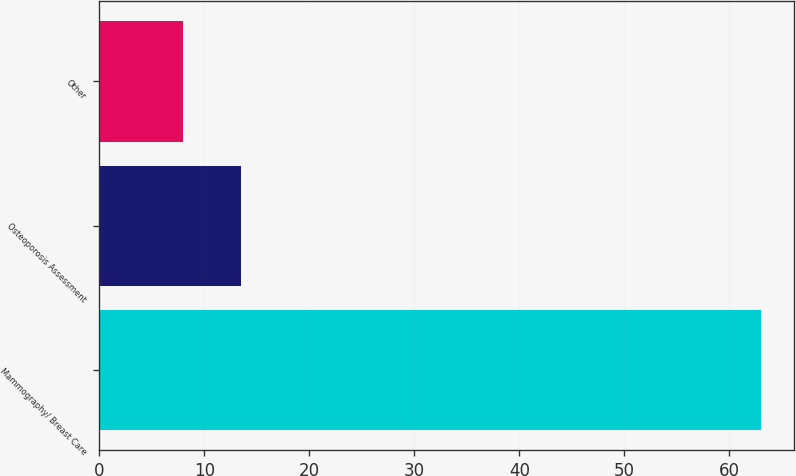Convert chart. <chart><loc_0><loc_0><loc_500><loc_500><bar_chart><fcel>Mammography/ Breast Care<fcel>Osteoporosis Assessment<fcel>Other<nl><fcel>63<fcel>13.5<fcel>8<nl></chart> 